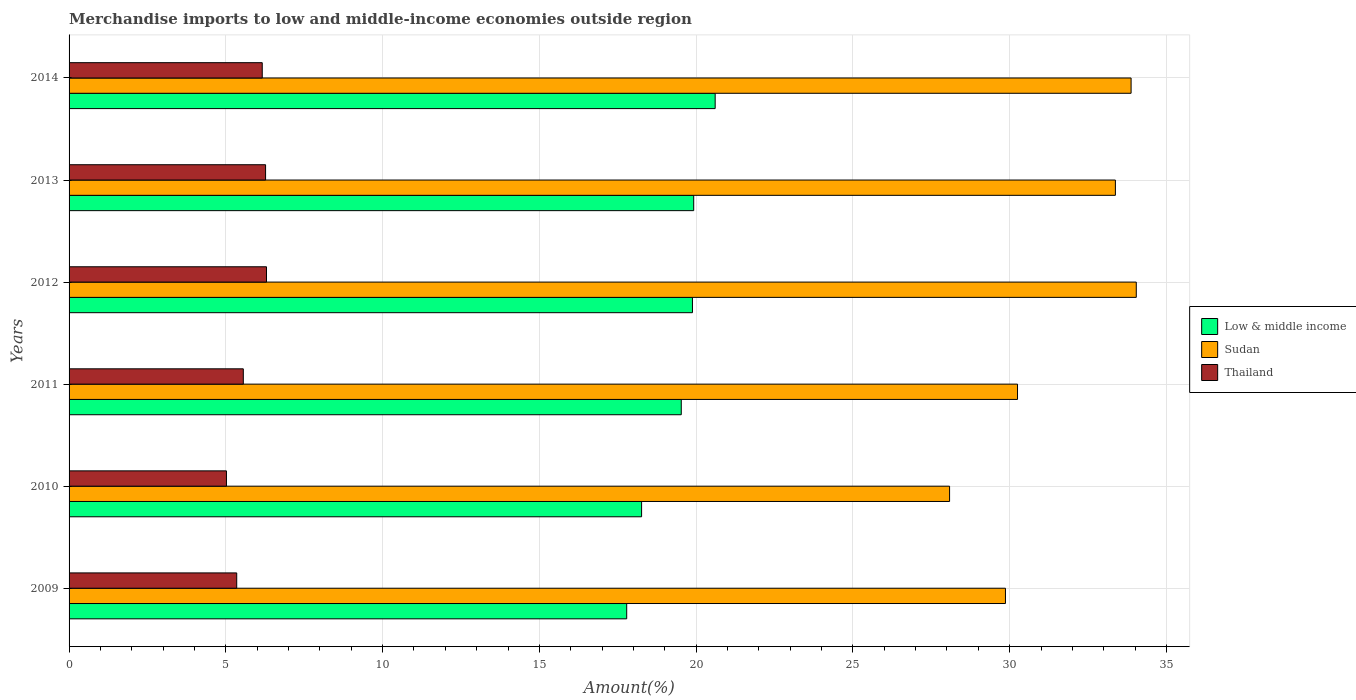Are the number of bars per tick equal to the number of legend labels?
Keep it short and to the point. Yes. How many bars are there on the 6th tick from the bottom?
Offer a terse response. 3. What is the percentage of amount earned from merchandise imports in Low & middle income in 2013?
Your answer should be very brief. 19.92. Across all years, what is the maximum percentage of amount earned from merchandise imports in Thailand?
Keep it short and to the point. 6.3. Across all years, what is the minimum percentage of amount earned from merchandise imports in Sudan?
Your response must be concise. 28.08. In which year was the percentage of amount earned from merchandise imports in Low & middle income maximum?
Offer a terse response. 2014. In which year was the percentage of amount earned from merchandise imports in Thailand minimum?
Make the answer very short. 2010. What is the total percentage of amount earned from merchandise imports in Low & middle income in the graph?
Your answer should be very brief. 115.98. What is the difference between the percentage of amount earned from merchandise imports in Low & middle income in 2010 and that in 2011?
Offer a very short reply. -1.27. What is the difference between the percentage of amount earned from merchandise imports in Thailand in 2010 and the percentage of amount earned from merchandise imports in Low & middle income in 2011?
Give a very brief answer. -14.51. What is the average percentage of amount earned from merchandise imports in Thailand per year?
Ensure brevity in your answer.  5.77. In the year 2011, what is the difference between the percentage of amount earned from merchandise imports in Thailand and percentage of amount earned from merchandise imports in Low & middle income?
Keep it short and to the point. -13.97. In how many years, is the percentage of amount earned from merchandise imports in Sudan greater than 12 %?
Your answer should be very brief. 6. What is the ratio of the percentage of amount earned from merchandise imports in Low & middle income in 2011 to that in 2014?
Offer a very short reply. 0.95. Is the difference between the percentage of amount earned from merchandise imports in Thailand in 2011 and 2013 greater than the difference between the percentage of amount earned from merchandise imports in Low & middle income in 2011 and 2013?
Offer a very short reply. No. What is the difference between the highest and the second highest percentage of amount earned from merchandise imports in Sudan?
Your answer should be very brief. 0.17. What is the difference between the highest and the lowest percentage of amount earned from merchandise imports in Low & middle income?
Provide a short and direct response. 2.82. In how many years, is the percentage of amount earned from merchandise imports in Sudan greater than the average percentage of amount earned from merchandise imports in Sudan taken over all years?
Offer a very short reply. 3. Is the sum of the percentage of amount earned from merchandise imports in Sudan in 2011 and 2013 greater than the maximum percentage of amount earned from merchandise imports in Thailand across all years?
Offer a terse response. Yes. What does the 1st bar from the top in 2014 represents?
Provide a short and direct response. Thailand. What does the 3rd bar from the bottom in 2014 represents?
Offer a very short reply. Thailand. How many bars are there?
Your answer should be compact. 18. Does the graph contain any zero values?
Provide a short and direct response. No. Does the graph contain grids?
Your response must be concise. Yes. What is the title of the graph?
Keep it short and to the point. Merchandise imports to low and middle-income economies outside region. What is the label or title of the X-axis?
Offer a very short reply. Amount(%). What is the Amount(%) in Low & middle income in 2009?
Make the answer very short. 17.78. What is the Amount(%) of Sudan in 2009?
Make the answer very short. 29.86. What is the Amount(%) in Thailand in 2009?
Make the answer very short. 5.35. What is the Amount(%) in Low & middle income in 2010?
Keep it short and to the point. 18.26. What is the Amount(%) in Sudan in 2010?
Provide a short and direct response. 28.08. What is the Amount(%) of Thailand in 2010?
Your answer should be very brief. 5.02. What is the Amount(%) in Low & middle income in 2011?
Your answer should be very brief. 19.53. What is the Amount(%) of Sudan in 2011?
Offer a terse response. 30.25. What is the Amount(%) of Thailand in 2011?
Keep it short and to the point. 5.56. What is the Amount(%) of Low & middle income in 2012?
Keep it short and to the point. 19.88. What is the Amount(%) in Sudan in 2012?
Make the answer very short. 34.04. What is the Amount(%) in Thailand in 2012?
Your answer should be very brief. 6.3. What is the Amount(%) of Low & middle income in 2013?
Ensure brevity in your answer.  19.92. What is the Amount(%) of Sudan in 2013?
Ensure brevity in your answer.  33.37. What is the Amount(%) in Thailand in 2013?
Offer a terse response. 6.27. What is the Amount(%) of Low & middle income in 2014?
Provide a short and direct response. 20.61. What is the Amount(%) of Sudan in 2014?
Provide a succinct answer. 33.87. What is the Amount(%) of Thailand in 2014?
Keep it short and to the point. 6.16. Across all years, what is the maximum Amount(%) of Low & middle income?
Offer a terse response. 20.61. Across all years, what is the maximum Amount(%) in Sudan?
Ensure brevity in your answer.  34.04. Across all years, what is the maximum Amount(%) of Thailand?
Make the answer very short. 6.3. Across all years, what is the minimum Amount(%) of Low & middle income?
Offer a terse response. 17.78. Across all years, what is the minimum Amount(%) in Sudan?
Offer a very short reply. 28.08. Across all years, what is the minimum Amount(%) of Thailand?
Your answer should be very brief. 5.02. What is the total Amount(%) of Low & middle income in the graph?
Ensure brevity in your answer.  115.98. What is the total Amount(%) of Sudan in the graph?
Give a very brief answer. 189.48. What is the total Amount(%) of Thailand in the graph?
Your answer should be very brief. 34.65. What is the difference between the Amount(%) of Low & middle income in 2009 and that in 2010?
Your answer should be very brief. -0.48. What is the difference between the Amount(%) of Sudan in 2009 and that in 2010?
Ensure brevity in your answer.  1.78. What is the difference between the Amount(%) of Thailand in 2009 and that in 2010?
Your answer should be very brief. 0.33. What is the difference between the Amount(%) of Low & middle income in 2009 and that in 2011?
Offer a terse response. -1.74. What is the difference between the Amount(%) in Sudan in 2009 and that in 2011?
Offer a very short reply. -0.38. What is the difference between the Amount(%) of Thailand in 2009 and that in 2011?
Your response must be concise. -0.21. What is the difference between the Amount(%) of Low & middle income in 2009 and that in 2012?
Your response must be concise. -2.1. What is the difference between the Amount(%) in Sudan in 2009 and that in 2012?
Provide a short and direct response. -4.17. What is the difference between the Amount(%) of Thailand in 2009 and that in 2012?
Keep it short and to the point. -0.95. What is the difference between the Amount(%) in Low & middle income in 2009 and that in 2013?
Offer a very short reply. -2.14. What is the difference between the Amount(%) in Sudan in 2009 and that in 2013?
Offer a terse response. -3.51. What is the difference between the Amount(%) of Thailand in 2009 and that in 2013?
Offer a terse response. -0.92. What is the difference between the Amount(%) of Low & middle income in 2009 and that in 2014?
Give a very brief answer. -2.82. What is the difference between the Amount(%) in Sudan in 2009 and that in 2014?
Provide a succinct answer. -4.01. What is the difference between the Amount(%) in Thailand in 2009 and that in 2014?
Your answer should be compact. -0.81. What is the difference between the Amount(%) in Low & middle income in 2010 and that in 2011?
Offer a very short reply. -1.27. What is the difference between the Amount(%) in Sudan in 2010 and that in 2011?
Ensure brevity in your answer.  -2.17. What is the difference between the Amount(%) in Thailand in 2010 and that in 2011?
Give a very brief answer. -0.54. What is the difference between the Amount(%) in Low & middle income in 2010 and that in 2012?
Offer a very short reply. -1.62. What is the difference between the Amount(%) of Sudan in 2010 and that in 2012?
Ensure brevity in your answer.  -5.96. What is the difference between the Amount(%) of Thailand in 2010 and that in 2012?
Your response must be concise. -1.28. What is the difference between the Amount(%) of Low & middle income in 2010 and that in 2013?
Keep it short and to the point. -1.66. What is the difference between the Amount(%) in Sudan in 2010 and that in 2013?
Give a very brief answer. -5.29. What is the difference between the Amount(%) of Thailand in 2010 and that in 2013?
Make the answer very short. -1.25. What is the difference between the Amount(%) in Low & middle income in 2010 and that in 2014?
Your response must be concise. -2.35. What is the difference between the Amount(%) of Sudan in 2010 and that in 2014?
Make the answer very short. -5.79. What is the difference between the Amount(%) in Thailand in 2010 and that in 2014?
Provide a short and direct response. -1.14. What is the difference between the Amount(%) in Low & middle income in 2011 and that in 2012?
Your response must be concise. -0.36. What is the difference between the Amount(%) of Sudan in 2011 and that in 2012?
Provide a succinct answer. -3.79. What is the difference between the Amount(%) in Thailand in 2011 and that in 2012?
Offer a terse response. -0.74. What is the difference between the Amount(%) in Low & middle income in 2011 and that in 2013?
Offer a terse response. -0.4. What is the difference between the Amount(%) of Sudan in 2011 and that in 2013?
Provide a short and direct response. -3.12. What is the difference between the Amount(%) of Thailand in 2011 and that in 2013?
Provide a short and direct response. -0.71. What is the difference between the Amount(%) in Low & middle income in 2011 and that in 2014?
Ensure brevity in your answer.  -1.08. What is the difference between the Amount(%) of Sudan in 2011 and that in 2014?
Offer a very short reply. -3.62. What is the difference between the Amount(%) of Thailand in 2011 and that in 2014?
Your answer should be very brief. -0.6. What is the difference between the Amount(%) of Low & middle income in 2012 and that in 2013?
Your response must be concise. -0.04. What is the difference between the Amount(%) in Sudan in 2012 and that in 2013?
Offer a terse response. 0.67. What is the difference between the Amount(%) in Thailand in 2012 and that in 2013?
Give a very brief answer. 0.03. What is the difference between the Amount(%) in Low & middle income in 2012 and that in 2014?
Provide a short and direct response. -0.72. What is the difference between the Amount(%) of Sudan in 2012 and that in 2014?
Offer a terse response. 0.17. What is the difference between the Amount(%) in Thailand in 2012 and that in 2014?
Ensure brevity in your answer.  0.14. What is the difference between the Amount(%) in Low & middle income in 2013 and that in 2014?
Keep it short and to the point. -0.68. What is the difference between the Amount(%) in Sudan in 2013 and that in 2014?
Offer a terse response. -0.5. What is the difference between the Amount(%) of Thailand in 2013 and that in 2014?
Provide a short and direct response. 0.11. What is the difference between the Amount(%) in Low & middle income in 2009 and the Amount(%) in Sudan in 2010?
Make the answer very short. -10.3. What is the difference between the Amount(%) in Low & middle income in 2009 and the Amount(%) in Thailand in 2010?
Provide a short and direct response. 12.77. What is the difference between the Amount(%) of Sudan in 2009 and the Amount(%) of Thailand in 2010?
Make the answer very short. 24.84. What is the difference between the Amount(%) in Low & middle income in 2009 and the Amount(%) in Sudan in 2011?
Offer a very short reply. -12.46. What is the difference between the Amount(%) in Low & middle income in 2009 and the Amount(%) in Thailand in 2011?
Provide a short and direct response. 12.23. What is the difference between the Amount(%) of Sudan in 2009 and the Amount(%) of Thailand in 2011?
Offer a very short reply. 24.31. What is the difference between the Amount(%) of Low & middle income in 2009 and the Amount(%) of Sudan in 2012?
Your response must be concise. -16.25. What is the difference between the Amount(%) in Low & middle income in 2009 and the Amount(%) in Thailand in 2012?
Make the answer very short. 11.49. What is the difference between the Amount(%) in Sudan in 2009 and the Amount(%) in Thailand in 2012?
Your answer should be compact. 23.57. What is the difference between the Amount(%) in Low & middle income in 2009 and the Amount(%) in Sudan in 2013?
Keep it short and to the point. -15.59. What is the difference between the Amount(%) in Low & middle income in 2009 and the Amount(%) in Thailand in 2013?
Keep it short and to the point. 11.52. What is the difference between the Amount(%) in Sudan in 2009 and the Amount(%) in Thailand in 2013?
Give a very brief answer. 23.6. What is the difference between the Amount(%) in Low & middle income in 2009 and the Amount(%) in Sudan in 2014?
Ensure brevity in your answer.  -16.09. What is the difference between the Amount(%) of Low & middle income in 2009 and the Amount(%) of Thailand in 2014?
Your answer should be compact. 11.62. What is the difference between the Amount(%) of Sudan in 2009 and the Amount(%) of Thailand in 2014?
Your answer should be compact. 23.7. What is the difference between the Amount(%) in Low & middle income in 2010 and the Amount(%) in Sudan in 2011?
Keep it short and to the point. -11.99. What is the difference between the Amount(%) of Low & middle income in 2010 and the Amount(%) of Thailand in 2011?
Offer a terse response. 12.7. What is the difference between the Amount(%) in Sudan in 2010 and the Amount(%) in Thailand in 2011?
Make the answer very short. 22.53. What is the difference between the Amount(%) of Low & middle income in 2010 and the Amount(%) of Sudan in 2012?
Keep it short and to the point. -15.78. What is the difference between the Amount(%) of Low & middle income in 2010 and the Amount(%) of Thailand in 2012?
Your answer should be very brief. 11.96. What is the difference between the Amount(%) in Sudan in 2010 and the Amount(%) in Thailand in 2012?
Keep it short and to the point. 21.79. What is the difference between the Amount(%) in Low & middle income in 2010 and the Amount(%) in Sudan in 2013?
Ensure brevity in your answer.  -15.11. What is the difference between the Amount(%) in Low & middle income in 2010 and the Amount(%) in Thailand in 2013?
Offer a terse response. 11.99. What is the difference between the Amount(%) in Sudan in 2010 and the Amount(%) in Thailand in 2013?
Offer a terse response. 21.82. What is the difference between the Amount(%) of Low & middle income in 2010 and the Amount(%) of Sudan in 2014?
Provide a short and direct response. -15.61. What is the difference between the Amount(%) in Low & middle income in 2010 and the Amount(%) in Thailand in 2014?
Your response must be concise. 12.1. What is the difference between the Amount(%) of Sudan in 2010 and the Amount(%) of Thailand in 2014?
Ensure brevity in your answer.  21.92. What is the difference between the Amount(%) of Low & middle income in 2011 and the Amount(%) of Sudan in 2012?
Provide a succinct answer. -14.51. What is the difference between the Amount(%) of Low & middle income in 2011 and the Amount(%) of Thailand in 2012?
Provide a succinct answer. 13.23. What is the difference between the Amount(%) of Sudan in 2011 and the Amount(%) of Thailand in 2012?
Ensure brevity in your answer.  23.95. What is the difference between the Amount(%) of Low & middle income in 2011 and the Amount(%) of Sudan in 2013?
Give a very brief answer. -13.85. What is the difference between the Amount(%) in Low & middle income in 2011 and the Amount(%) in Thailand in 2013?
Provide a succinct answer. 13.26. What is the difference between the Amount(%) in Sudan in 2011 and the Amount(%) in Thailand in 2013?
Your response must be concise. 23.98. What is the difference between the Amount(%) in Low & middle income in 2011 and the Amount(%) in Sudan in 2014?
Give a very brief answer. -14.35. What is the difference between the Amount(%) of Low & middle income in 2011 and the Amount(%) of Thailand in 2014?
Provide a succinct answer. 13.36. What is the difference between the Amount(%) in Sudan in 2011 and the Amount(%) in Thailand in 2014?
Provide a succinct answer. 24.09. What is the difference between the Amount(%) of Low & middle income in 2012 and the Amount(%) of Sudan in 2013?
Offer a terse response. -13.49. What is the difference between the Amount(%) of Low & middle income in 2012 and the Amount(%) of Thailand in 2013?
Keep it short and to the point. 13.61. What is the difference between the Amount(%) in Sudan in 2012 and the Amount(%) in Thailand in 2013?
Your response must be concise. 27.77. What is the difference between the Amount(%) in Low & middle income in 2012 and the Amount(%) in Sudan in 2014?
Your response must be concise. -13.99. What is the difference between the Amount(%) in Low & middle income in 2012 and the Amount(%) in Thailand in 2014?
Ensure brevity in your answer.  13.72. What is the difference between the Amount(%) of Sudan in 2012 and the Amount(%) of Thailand in 2014?
Your response must be concise. 27.88. What is the difference between the Amount(%) of Low & middle income in 2013 and the Amount(%) of Sudan in 2014?
Keep it short and to the point. -13.95. What is the difference between the Amount(%) in Low & middle income in 2013 and the Amount(%) in Thailand in 2014?
Your response must be concise. 13.76. What is the difference between the Amount(%) of Sudan in 2013 and the Amount(%) of Thailand in 2014?
Keep it short and to the point. 27.21. What is the average Amount(%) in Low & middle income per year?
Offer a very short reply. 19.33. What is the average Amount(%) in Sudan per year?
Your answer should be very brief. 31.58. What is the average Amount(%) of Thailand per year?
Ensure brevity in your answer.  5.77. In the year 2009, what is the difference between the Amount(%) of Low & middle income and Amount(%) of Sudan?
Provide a short and direct response. -12.08. In the year 2009, what is the difference between the Amount(%) in Low & middle income and Amount(%) in Thailand?
Offer a terse response. 12.44. In the year 2009, what is the difference between the Amount(%) in Sudan and Amount(%) in Thailand?
Offer a terse response. 24.52. In the year 2010, what is the difference between the Amount(%) of Low & middle income and Amount(%) of Sudan?
Your response must be concise. -9.82. In the year 2010, what is the difference between the Amount(%) in Low & middle income and Amount(%) in Thailand?
Ensure brevity in your answer.  13.24. In the year 2010, what is the difference between the Amount(%) in Sudan and Amount(%) in Thailand?
Offer a very short reply. 23.06. In the year 2011, what is the difference between the Amount(%) of Low & middle income and Amount(%) of Sudan?
Your response must be concise. -10.72. In the year 2011, what is the difference between the Amount(%) of Low & middle income and Amount(%) of Thailand?
Offer a very short reply. 13.97. In the year 2011, what is the difference between the Amount(%) in Sudan and Amount(%) in Thailand?
Ensure brevity in your answer.  24.69. In the year 2012, what is the difference between the Amount(%) in Low & middle income and Amount(%) in Sudan?
Ensure brevity in your answer.  -14.16. In the year 2012, what is the difference between the Amount(%) in Low & middle income and Amount(%) in Thailand?
Your answer should be compact. 13.59. In the year 2012, what is the difference between the Amount(%) in Sudan and Amount(%) in Thailand?
Your answer should be compact. 27.74. In the year 2013, what is the difference between the Amount(%) in Low & middle income and Amount(%) in Sudan?
Ensure brevity in your answer.  -13.45. In the year 2013, what is the difference between the Amount(%) in Low & middle income and Amount(%) in Thailand?
Your response must be concise. 13.65. In the year 2013, what is the difference between the Amount(%) of Sudan and Amount(%) of Thailand?
Your answer should be very brief. 27.1. In the year 2014, what is the difference between the Amount(%) of Low & middle income and Amount(%) of Sudan?
Give a very brief answer. -13.27. In the year 2014, what is the difference between the Amount(%) in Low & middle income and Amount(%) in Thailand?
Provide a succinct answer. 14.45. In the year 2014, what is the difference between the Amount(%) of Sudan and Amount(%) of Thailand?
Offer a very short reply. 27.71. What is the ratio of the Amount(%) in Low & middle income in 2009 to that in 2010?
Your answer should be compact. 0.97. What is the ratio of the Amount(%) of Sudan in 2009 to that in 2010?
Provide a succinct answer. 1.06. What is the ratio of the Amount(%) in Thailand in 2009 to that in 2010?
Provide a succinct answer. 1.07. What is the ratio of the Amount(%) of Low & middle income in 2009 to that in 2011?
Keep it short and to the point. 0.91. What is the ratio of the Amount(%) in Sudan in 2009 to that in 2011?
Your answer should be very brief. 0.99. What is the ratio of the Amount(%) of Thailand in 2009 to that in 2011?
Give a very brief answer. 0.96. What is the ratio of the Amount(%) in Low & middle income in 2009 to that in 2012?
Ensure brevity in your answer.  0.89. What is the ratio of the Amount(%) in Sudan in 2009 to that in 2012?
Ensure brevity in your answer.  0.88. What is the ratio of the Amount(%) of Thailand in 2009 to that in 2012?
Give a very brief answer. 0.85. What is the ratio of the Amount(%) of Low & middle income in 2009 to that in 2013?
Offer a terse response. 0.89. What is the ratio of the Amount(%) of Sudan in 2009 to that in 2013?
Provide a succinct answer. 0.89. What is the ratio of the Amount(%) of Thailand in 2009 to that in 2013?
Your answer should be compact. 0.85. What is the ratio of the Amount(%) in Low & middle income in 2009 to that in 2014?
Keep it short and to the point. 0.86. What is the ratio of the Amount(%) in Sudan in 2009 to that in 2014?
Ensure brevity in your answer.  0.88. What is the ratio of the Amount(%) of Thailand in 2009 to that in 2014?
Your response must be concise. 0.87. What is the ratio of the Amount(%) in Low & middle income in 2010 to that in 2011?
Your answer should be compact. 0.94. What is the ratio of the Amount(%) in Sudan in 2010 to that in 2011?
Ensure brevity in your answer.  0.93. What is the ratio of the Amount(%) in Thailand in 2010 to that in 2011?
Provide a short and direct response. 0.9. What is the ratio of the Amount(%) of Low & middle income in 2010 to that in 2012?
Offer a terse response. 0.92. What is the ratio of the Amount(%) in Sudan in 2010 to that in 2012?
Your answer should be very brief. 0.82. What is the ratio of the Amount(%) in Thailand in 2010 to that in 2012?
Your answer should be very brief. 0.8. What is the ratio of the Amount(%) in Low & middle income in 2010 to that in 2013?
Give a very brief answer. 0.92. What is the ratio of the Amount(%) in Sudan in 2010 to that in 2013?
Provide a short and direct response. 0.84. What is the ratio of the Amount(%) of Thailand in 2010 to that in 2013?
Ensure brevity in your answer.  0.8. What is the ratio of the Amount(%) in Low & middle income in 2010 to that in 2014?
Provide a short and direct response. 0.89. What is the ratio of the Amount(%) of Sudan in 2010 to that in 2014?
Offer a terse response. 0.83. What is the ratio of the Amount(%) in Thailand in 2010 to that in 2014?
Your answer should be very brief. 0.81. What is the ratio of the Amount(%) of Low & middle income in 2011 to that in 2012?
Offer a very short reply. 0.98. What is the ratio of the Amount(%) of Sudan in 2011 to that in 2012?
Give a very brief answer. 0.89. What is the ratio of the Amount(%) in Thailand in 2011 to that in 2012?
Provide a short and direct response. 0.88. What is the ratio of the Amount(%) in Low & middle income in 2011 to that in 2013?
Provide a succinct answer. 0.98. What is the ratio of the Amount(%) of Sudan in 2011 to that in 2013?
Offer a very short reply. 0.91. What is the ratio of the Amount(%) in Thailand in 2011 to that in 2013?
Provide a short and direct response. 0.89. What is the ratio of the Amount(%) in Low & middle income in 2011 to that in 2014?
Ensure brevity in your answer.  0.95. What is the ratio of the Amount(%) of Sudan in 2011 to that in 2014?
Give a very brief answer. 0.89. What is the ratio of the Amount(%) of Thailand in 2011 to that in 2014?
Ensure brevity in your answer.  0.9. What is the ratio of the Amount(%) of Low & middle income in 2012 to that in 2014?
Provide a short and direct response. 0.96. What is the ratio of the Amount(%) in Sudan in 2012 to that in 2014?
Provide a short and direct response. 1. What is the ratio of the Amount(%) of Low & middle income in 2013 to that in 2014?
Give a very brief answer. 0.97. What is the ratio of the Amount(%) of Sudan in 2013 to that in 2014?
Provide a succinct answer. 0.99. What is the ratio of the Amount(%) in Thailand in 2013 to that in 2014?
Your response must be concise. 1.02. What is the difference between the highest and the second highest Amount(%) of Low & middle income?
Ensure brevity in your answer.  0.68. What is the difference between the highest and the second highest Amount(%) of Sudan?
Ensure brevity in your answer.  0.17. What is the difference between the highest and the second highest Amount(%) in Thailand?
Ensure brevity in your answer.  0.03. What is the difference between the highest and the lowest Amount(%) in Low & middle income?
Your answer should be very brief. 2.82. What is the difference between the highest and the lowest Amount(%) in Sudan?
Your answer should be compact. 5.96. What is the difference between the highest and the lowest Amount(%) in Thailand?
Make the answer very short. 1.28. 